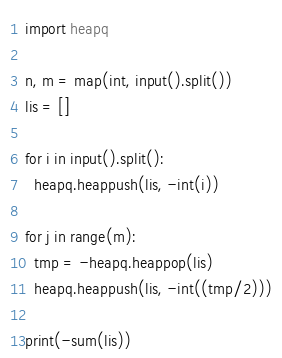<code> <loc_0><loc_0><loc_500><loc_500><_Python_>import heapq

n, m = map(int, input().split())
lis = []

for i in input().split():
  heapq.heappush(lis, -int(i))

for j in range(m):
  tmp = -heapq.heappop(lis)
  heapq.heappush(lis, -int((tmp/2)))

print(-sum(lis))</code> 